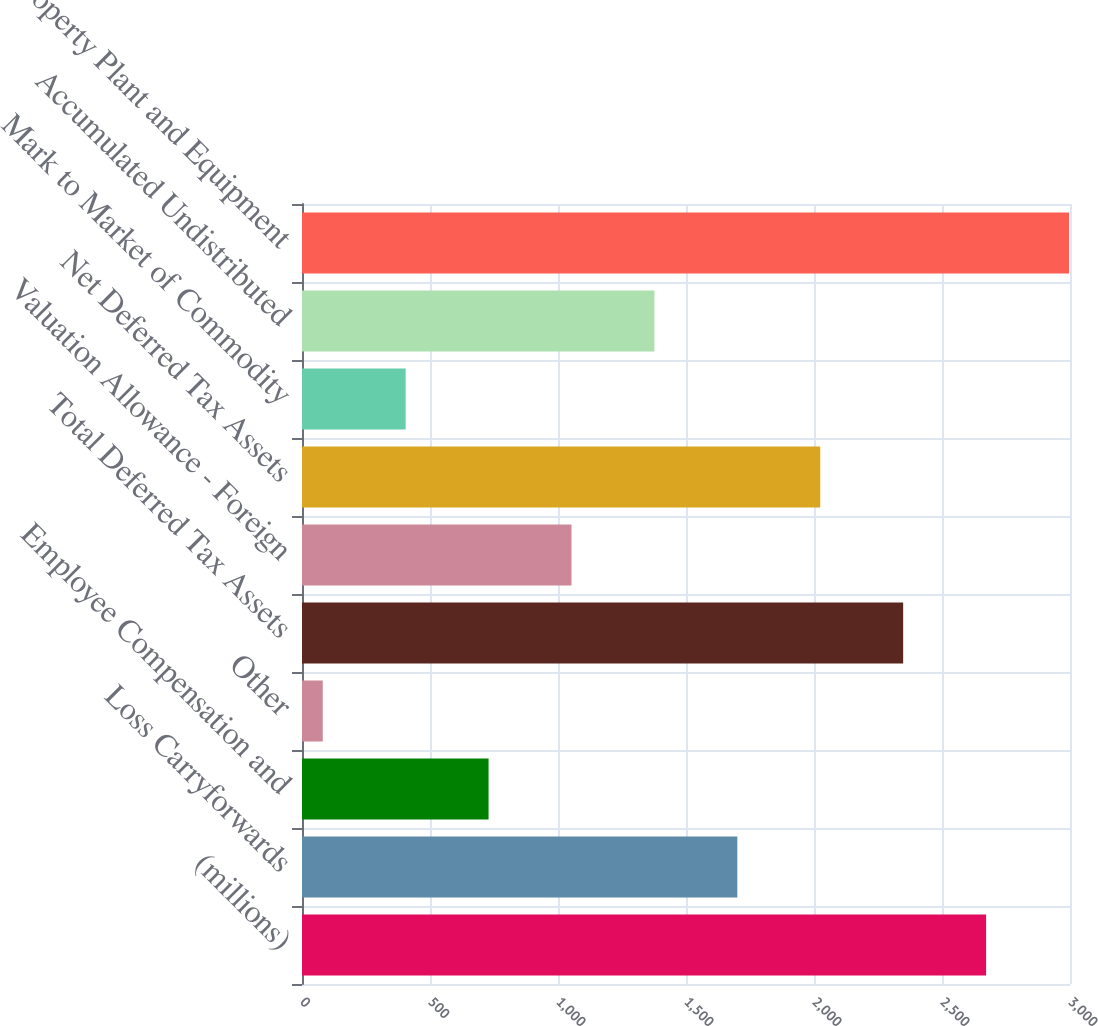Convert chart. <chart><loc_0><loc_0><loc_500><loc_500><bar_chart><fcel>(millions)<fcel>Loss Carryforwards<fcel>Employee Compensation and<fcel>Other<fcel>Total Deferred Tax Assets<fcel>Valuation Allowance - Foreign<fcel>Net Deferred Tax Assets<fcel>Mark to Market of Commodity<fcel>Accumulated Undistributed<fcel>Property Plant and Equipment<nl><fcel>2672.2<fcel>1700.5<fcel>728.8<fcel>81<fcel>2348.3<fcel>1052.7<fcel>2024.4<fcel>404.9<fcel>1376.6<fcel>2996.1<nl></chart> 